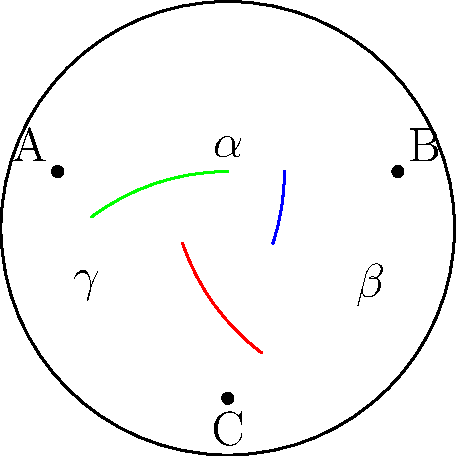As a tour guide in Cluny, you're explaining the unique geometry of the Romanesque architecture in the famous Cluny Abbey. To illustrate a point about non-Euclidean geometry, you draw a triangle on a hyperbolic plane using the Poincaré disk model. If the angles of this triangle are $\alpha$, $\beta$, and $\gamma$, what is the sum of these angles in relation to $\pi$ (180°)? To understand the sum of angles in a hyperbolic triangle:

1. In Euclidean geometry, the sum of angles in a triangle is always $\pi$ (180°).

2. However, in hyperbolic geometry, this is not the case. The sum of angles in a hyperbolic triangle is always less than $\pi$.

3. In the Poincaré disk model:
   - Straight lines are represented by arcs of circles that are perpendicular to the boundary circle.
   - The sum of angles in a triangle follows the formula: $\alpha + \beta + \gamma = \pi - A$, where $A$ is the area of the triangle in the hyperbolic plane.

4. Since the area $A$ is always positive in a hyperbolic plane, we can conclude that $\alpha + \beta + \gamma < \pi$.

5. The larger the triangle in the hyperbolic plane, the smaller the sum of its angles will be.

6. As the triangle gets infinitesimally small, the sum of its angles approaches $\pi$, but never reaches it.

Therefore, in a hyperbolic triangle, the sum of angles is always less than $\pi$ (180°).
Answer: $\alpha + \beta + \gamma < \pi$ 